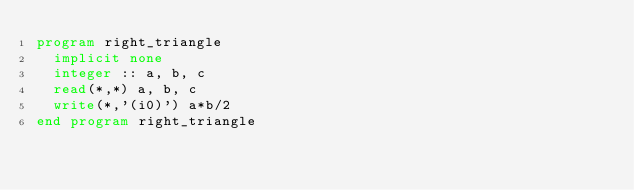Convert code to text. <code><loc_0><loc_0><loc_500><loc_500><_FORTRAN_>program right_triangle
  implicit none
  integer :: a, b, c
  read(*,*) a, b, c
  write(*,'(i0)') a*b/2
end program right_triangle</code> 